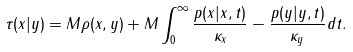Convert formula to latex. <formula><loc_0><loc_0><loc_500><loc_500>\tau ( x | y ) = M \rho ( x , y ) + M \int _ { 0 } ^ { \infty } \frac { p ( x | x , t ) } { \kappa _ { x } } - \frac { p ( y | y , t ) } { \kappa _ { y } } d t .</formula> 